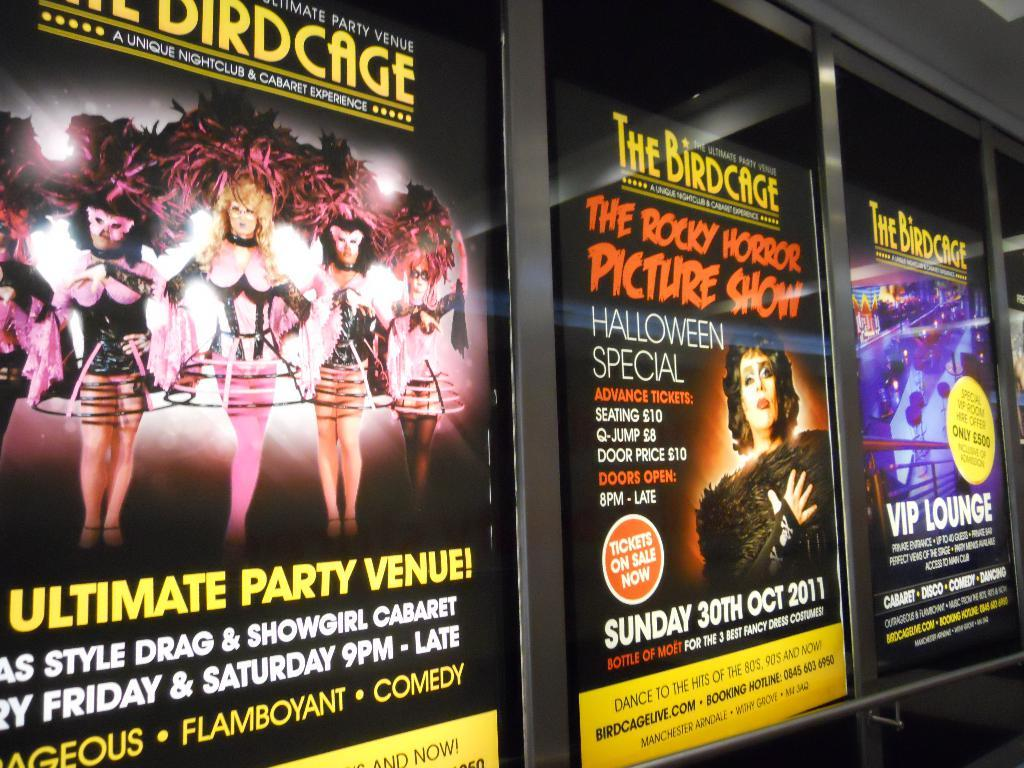<image>
Create a compact narrative representing the image presented. several movie posters for The Birdcage like VIP Lounge 